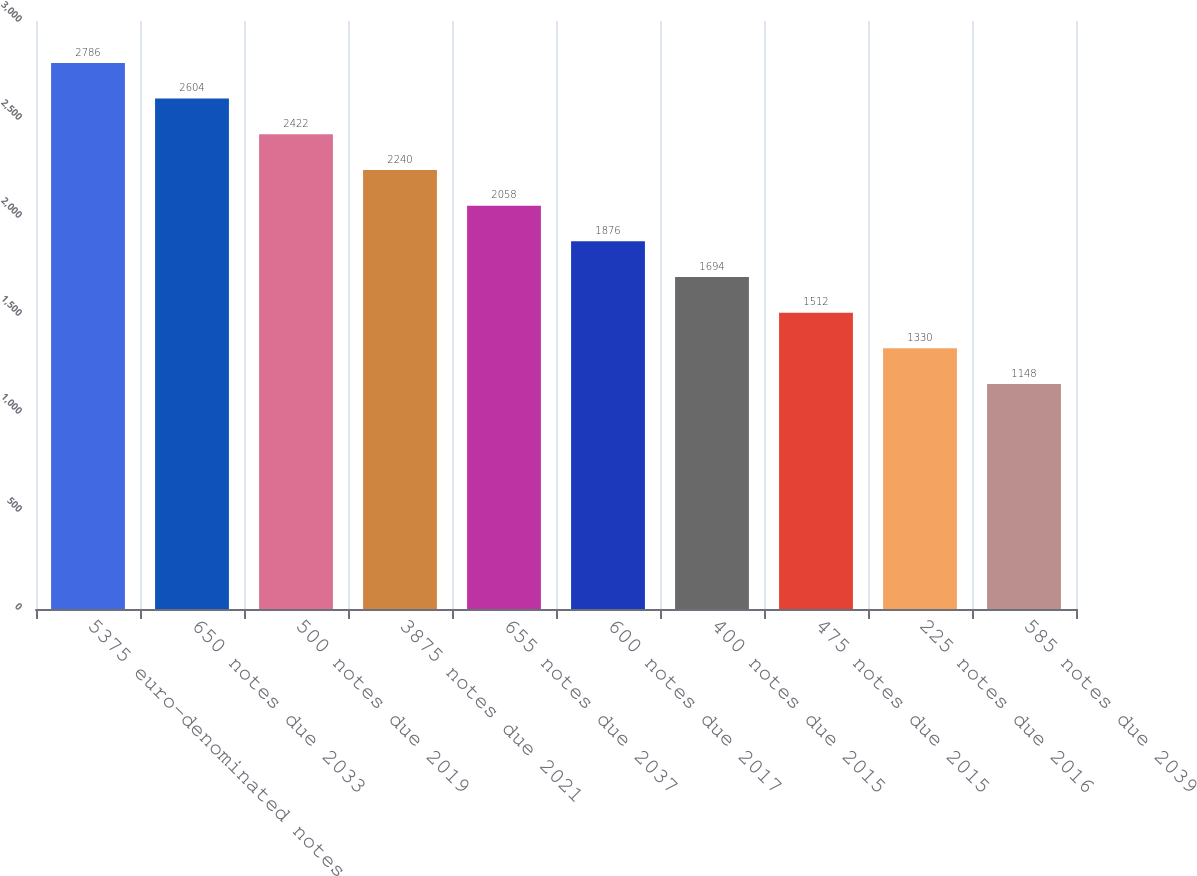Convert chart to OTSL. <chart><loc_0><loc_0><loc_500><loc_500><bar_chart><fcel>5375 euro-denominated notes<fcel>650 notes due 2033<fcel>500 notes due 2019<fcel>3875 notes due 2021<fcel>655 notes due 2037<fcel>600 notes due 2017<fcel>400 notes due 2015<fcel>475 notes due 2015<fcel>225 notes due 2016<fcel>585 notes due 2039<nl><fcel>2786<fcel>2604<fcel>2422<fcel>2240<fcel>2058<fcel>1876<fcel>1694<fcel>1512<fcel>1330<fcel>1148<nl></chart> 